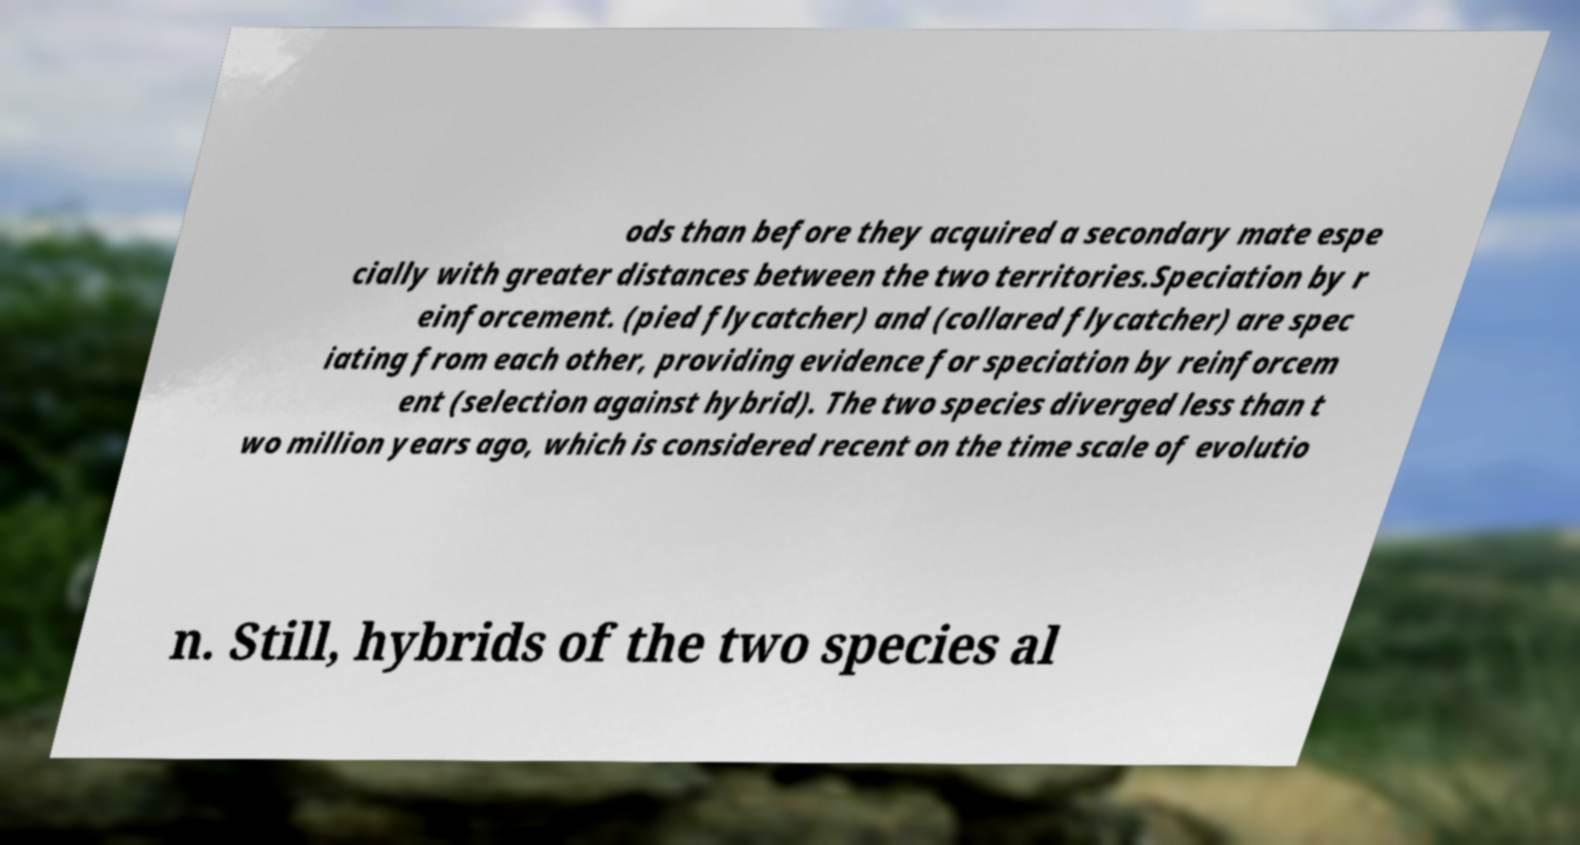Please read and relay the text visible in this image. What does it say? ods than before they acquired a secondary mate espe cially with greater distances between the two territories.Speciation by r einforcement. (pied flycatcher) and (collared flycatcher) are spec iating from each other, providing evidence for speciation by reinforcem ent (selection against hybrid). The two species diverged less than t wo million years ago, which is considered recent on the time scale of evolutio n. Still, hybrids of the two species al 